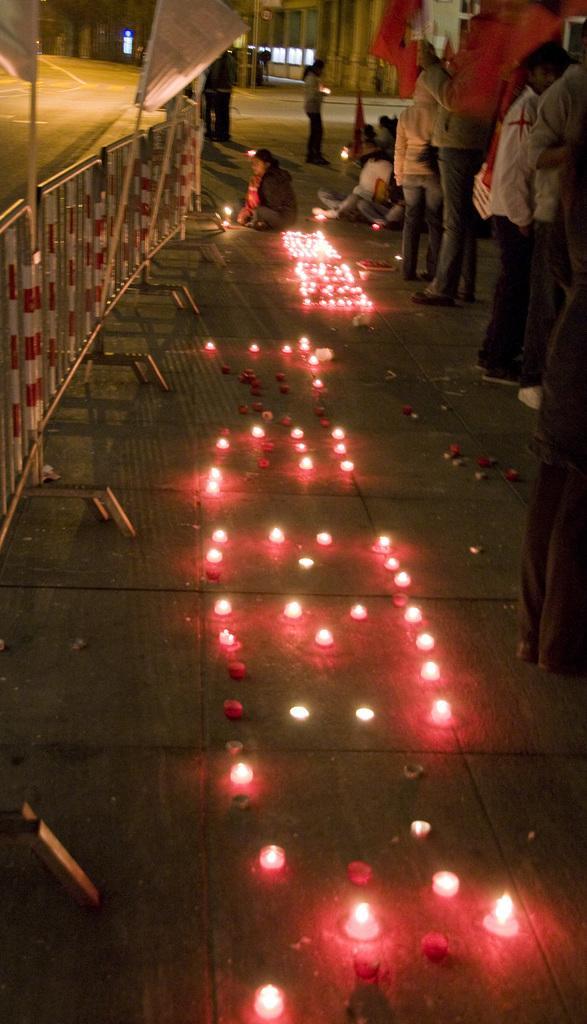Please provide a concise description of this image. In this image, we can see some lights on the ground, we can see the fence on the left side, on the right side, we can see some people standing. 